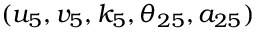<formula> <loc_0><loc_0><loc_500><loc_500>( u _ { 5 } , v _ { 5 } , k _ { 5 } , \theta _ { 2 5 } , a _ { 2 5 } )</formula> 